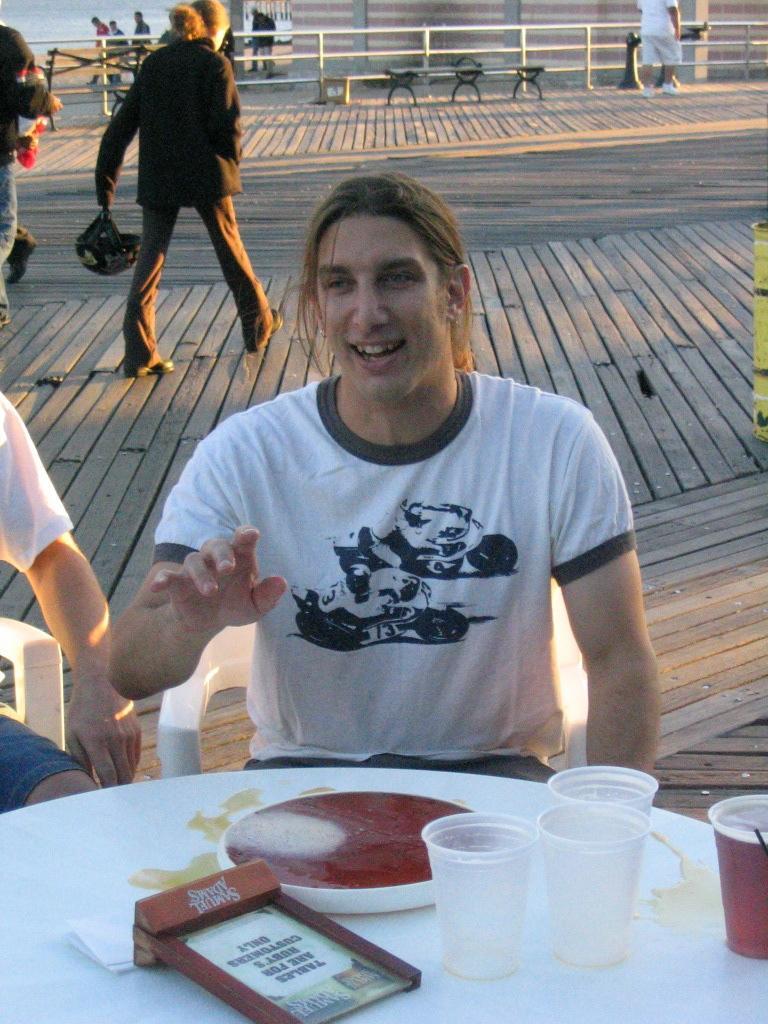In one or two sentences, can you explain what this image depicts? In this picture we can see two persons sitting on chairs in front of a table, there are some glasses and a board present on the table, in the background we can see some people walking, we can see fencing here. 